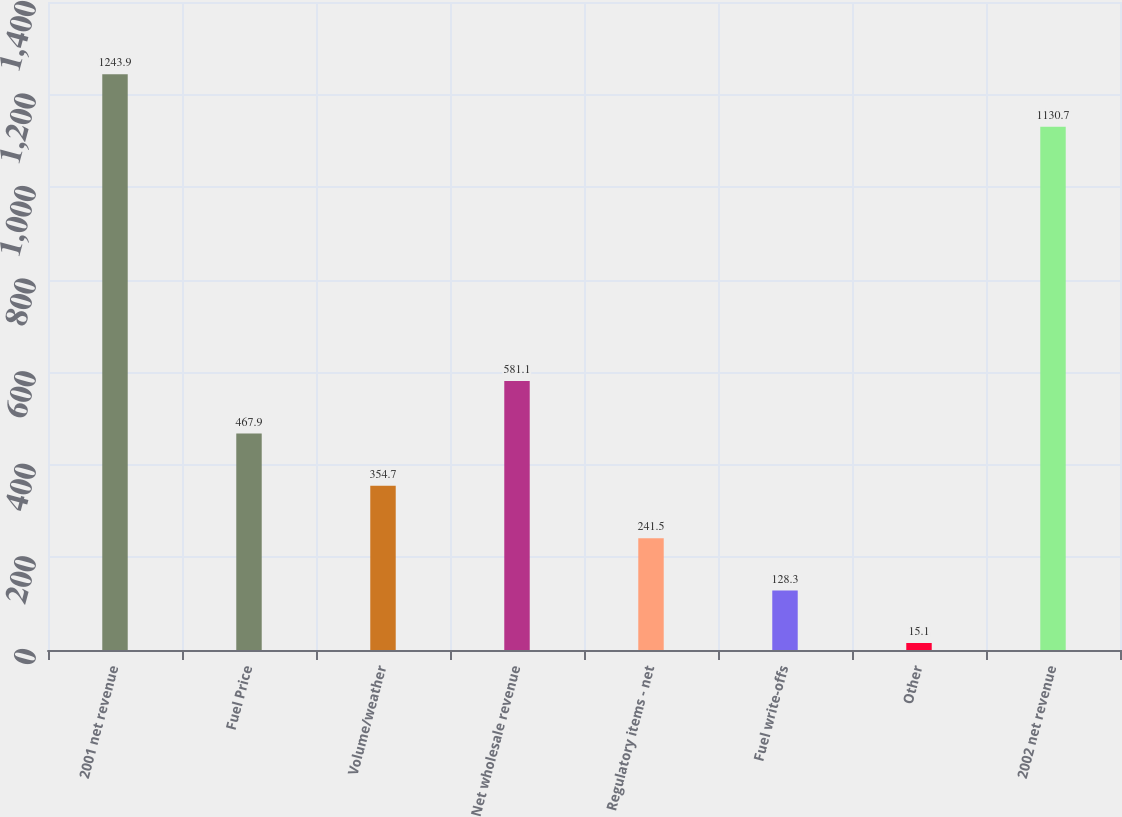Convert chart to OTSL. <chart><loc_0><loc_0><loc_500><loc_500><bar_chart><fcel>2001 net revenue<fcel>Fuel Price<fcel>Volume/weather<fcel>Net wholesale revenue<fcel>Regulatory items - net<fcel>Fuel write-offs<fcel>Other<fcel>2002 net revenue<nl><fcel>1243.9<fcel>467.9<fcel>354.7<fcel>581.1<fcel>241.5<fcel>128.3<fcel>15.1<fcel>1130.7<nl></chart> 